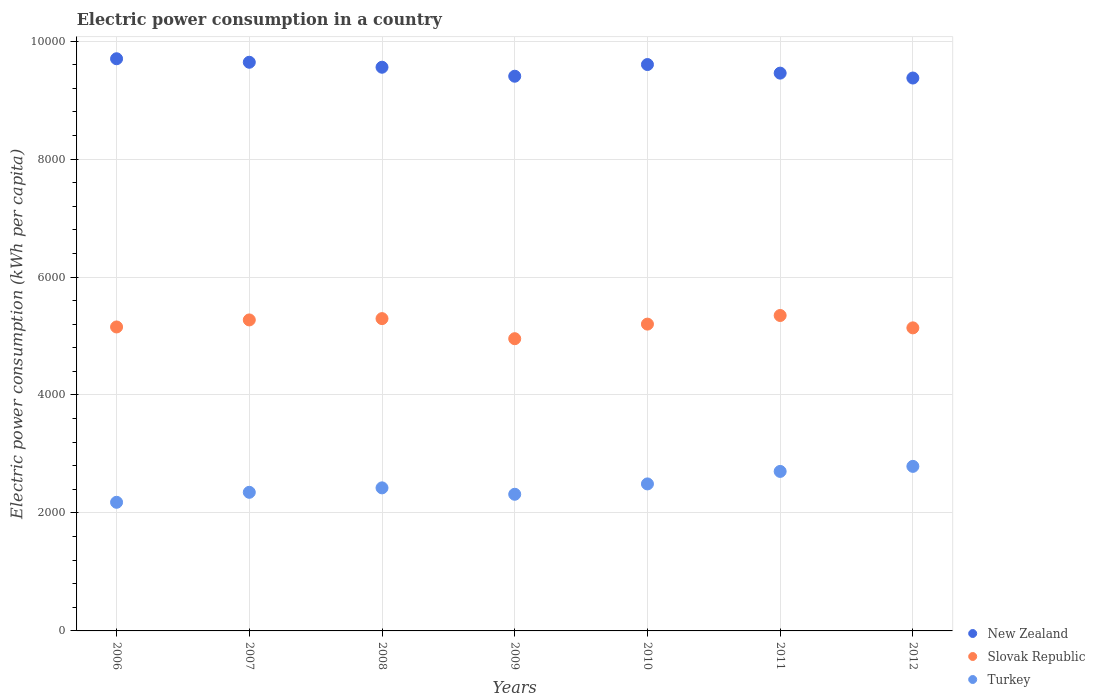How many different coloured dotlines are there?
Your answer should be compact. 3. What is the electric power consumption in in Slovak Republic in 2010?
Provide a succinct answer. 5201.4. Across all years, what is the maximum electric power consumption in in Slovak Republic?
Make the answer very short. 5347.53. Across all years, what is the minimum electric power consumption in in Slovak Republic?
Ensure brevity in your answer.  4954.14. What is the total electric power consumption in in Slovak Republic in the graph?
Your answer should be very brief. 3.64e+04. What is the difference between the electric power consumption in in Turkey in 2006 and that in 2011?
Provide a succinct answer. -523.33. What is the difference between the electric power consumption in in New Zealand in 2012 and the electric power consumption in in Slovak Republic in 2007?
Keep it short and to the point. 4101.06. What is the average electric power consumption in in Slovak Republic per year?
Your answer should be compact. 5194.4. In the year 2007, what is the difference between the electric power consumption in in Slovak Republic and electric power consumption in in Turkey?
Keep it short and to the point. 2922.49. What is the ratio of the electric power consumption in in Slovak Republic in 2008 to that in 2010?
Make the answer very short. 1.02. Is the electric power consumption in in Slovak Republic in 2006 less than that in 2011?
Your answer should be compact. Yes. Is the difference between the electric power consumption in in Slovak Republic in 2006 and 2012 greater than the difference between the electric power consumption in in Turkey in 2006 and 2012?
Your answer should be very brief. Yes. What is the difference between the highest and the second highest electric power consumption in in Turkey?
Give a very brief answer. 85.61. What is the difference between the highest and the lowest electric power consumption in in Slovak Republic?
Ensure brevity in your answer.  393.39. In how many years, is the electric power consumption in in Slovak Republic greater than the average electric power consumption in in Slovak Republic taken over all years?
Offer a terse response. 4. Does the electric power consumption in in Turkey monotonically increase over the years?
Provide a succinct answer. No. Is the electric power consumption in in Turkey strictly less than the electric power consumption in in Slovak Republic over the years?
Offer a terse response. Yes. How many years are there in the graph?
Make the answer very short. 7. Are the values on the major ticks of Y-axis written in scientific E-notation?
Your response must be concise. No. Where does the legend appear in the graph?
Ensure brevity in your answer.  Bottom right. How are the legend labels stacked?
Ensure brevity in your answer.  Vertical. What is the title of the graph?
Make the answer very short. Electric power consumption in a country. What is the label or title of the Y-axis?
Provide a short and direct response. Electric power consumption (kWh per capita). What is the Electric power consumption (kWh per capita) of New Zealand in 2006?
Give a very brief answer. 9700.09. What is the Electric power consumption (kWh per capita) of Slovak Republic in 2006?
Make the answer very short. 5153.12. What is the Electric power consumption (kWh per capita) in Turkey in 2006?
Make the answer very short. 2180.72. What is the Electric power consumption (kWh per capita) in New Zealand in 2007?
Offer a terse response. 9640.61. What is the Electric power consumption (kWh per capita) in Slovak Republic in 2007?
Offer a terse response. 5272.37. What is the Electric power consumption (kWh per capita) of Turkey in 2007?
Provide a short and direct response. 2349.88. What is the Electric power consumption (kWh per capita) in New Zealand in 2008?
Ensure brevity in your answer.  9556.32. What is the Electric power consumption (kWh per capita) in Slovak Republic in 2008?
Your response must be concise. 5294.44. What is the Electric power consumption (kWh per capita) of Turkey in 2008?
Provide a short and direct response. 2425.27. What is the Electric power consumption (kWh per capita) in New Zealand in 2009?
Make the answer very short. 9403.85. What is the Electric power consumption (kWh per capita) of Slovak Republic in 2009?
Provide a short and direct response. 4954.14. What is the Electric power consumption (kWh per capita) of Turkey in 2009?
Make the answer very short. 2316.64. What is the Electric power consumption (kWh per capita) in New Zealand in 2010?
Give a very brief answer. 9601.9. What is the Electric power consumption (kWh per capita) of Slovak Republic in 2010?
Make the answer very short. 5201.4. What is the Electric power consumption (kWh per capita) of Turkey in 2010?
Your answer should be compact. 2492.2. What is the Electric power consumption (kWh per capita) in New Zealand in 2011?
Offer a very short reply. 9456.2. What is the Electric power consumption (kWh per capita) in Slovak Republic in 2011?
Keep it short and to the point. 5347.53. What is the Electric power consumption (kWh per capita) in Turkey in 2011?
Provide a succinct answer. 2704.05. What is the Electric power consumption (kWh per capita) of New Zealand in 2012?
Keep it short and to the point. 9373.43. What is the Electric power consumption (kWh per capita) of Slovak Republic in 2012?
Provide a succinct answer. 5137.79. What is the Electric power consumption (kWh per capita) in Turkey in 2012?
Ensure brevity in your answer.  2789.66. Across all years, what is the maximum Electric power consumption (kWh per capita) in New Zealand?
Give a very brief answer. 9700.09. Across all years, what is the maximum Electric power consumption (kWh per capita) in Slovak Republic?
Give a very brief answer. 5347.53. Across all years, what is the maximum Electric power consumption (kWh per capita) of Turkey?
Provide a succinct answer. 2789.66. Across all years, what is the minimum Electric power consumption (kWh per capita) in New Zealand?
Offer a very short reply. 9373.43. Across all years, what is the minimum Electric power consumption (kWh per capita) of Slovak Republic?
Make the answer very short. 4954.14. Across all years, what is the minimum Electric power consumption (kWh per capita) in Turkey?
Your response must be concise. 2180.72. What is the total Electric power consumption (kWh per capita) of New Zealand in the graph?
Provide a succinct answer. 6.67e+04. What is the total Electric power consumption (kWh per capita) of Slovak Republic in the graph?
Offer a terse response. 3.64e+04. What is the total Electric power consumption (kWh per capita) in Turkey in the graph?
Provide a succinct answer. 1.73e+04. What is the difference between the Electric power consumption (kWh per capita) in New Zealand in 2006 and that in 2007?
Give a very brief answer. 59.48. What is the difference between the Electric power consumption (kWh per capita) of Slovak Republic in 2006 and that in 2007?
Make the answer very short. -119.25. What is the difference between the Electric power consumption (kWh per capita) in Turkey in 2006 and that in 2007?
Make the answer very short. -169.16. What is the difference between the Electric power consumption (kWh per capita) of New Zealand in 2006 and that in 2008?
Give a very brief answer. 143.77. What is the difference between the Electric power consumption (kWh per capita) of Slovak Republic in 2006 and that in 2008?
Provide a succinct answer. -141.31. What is the difference between the Electric power consumption (kWh per capita) in Turkey in 2006 and that in 2008?
Offer a terse response. -244.55. What is the difference between the Electric power consumption (kWh per capita) in New Zealand in 2006 and that in 2009?
Give a very brief answer. 296.24. What is the difference between the Electric power consumption (kWh per capita) in Slovak Republic in 2006 and that in 2009?
Make the answer very short. 198.98. What is the difference between the Electric power consumption (kWh per capita) of Turkey in 2006 and that in 2009?
Provide a succinct answer. -135.92. What is the difference between the Electric power consumption (kWh per capita) of New Zealand in 2006 and that in 2010?
Give a very brief answer. 98.19. What is the difference between the Electric power consumption (kWh per capita) in Slovak Republic in 2006 and that in 2010?
Offer a terse response. -48.28. What is the difference between the Electric power consumption (kWh per capita) of Turkey in 2006 and that in 2010?
Give a very brief answer. -311.48. What is the difference between the Electric power consumption (kWh per capita) in New Zealand in 2006 and that in 2011?
Offer a terse response. 243.89. What is the difference between the Electric power consumption (kWh per capita) in Slovak Republic in 2006 and that in 2011?
Give a very brief answer. -194.4. What is the difference between the Electric power consumption (kWh per capita) in Turkey in 2006 and that in 2011?
Give a very brief answer. -523.33. What is the difference between the Electric power consumption (kWh per capita) in New Zealand in 2006 and that in 2012?
Your response must be concise. 326.66. What is the difference between the Electric power consumption (kWh per capita) of Slovak Republic in 2006 and that in 2012?
Offer a terse response. 15.33. What is the difference between the Electric power consumption (kWh per capita) in Turkey in 2006 and that in 2012?
Give a very brief answer. -608.94. What is the difference between the Electric power consumption (kWh per capita) in New Zealand in 2007 and that in 2008?
Make the answer very short. 84.29. What is the difference between the Electric power consumption (kWh per capita) of Slovak Republic in 2007 and that in 2008?
Your answer should be compact. -22.06. What is the difference between the Electric power consumption (kWh per capita) in Turkey in 2007 and that in 2008?
Your response must be concise. -75.39. What is the difference between the Electric power consumption (kWh per capita) in New Zealand in 2007 and that in 2009?
Your answer should be very brief. 236.76. What is the difference between the Electric power consumption (kWh per capita) of Slovak Republic in 2007 and that in 2009?
Give a very brief answer. 318.23. What is the difference between the Electric power consumption (kWh per capita) of Turkey in 2007 and that in 2009?
Offer a terse response. 33.24. What is the difference between the Electric power consumption (kWh per capita) in New Zealand in 2007 and that in 2010?
Ensure brevity in your answer.  38.7. What is the difference between the Electric power consumption (kWh per capita) of Slovak Republic in 2007 and that in 2010?
Offer a very short reply. 70.97. What is the difference between the Electric power consumption (kWh per capita) of Turkey in 2007 and that in 2010?
Ensure brevity in your answer.  -142.32. What is the difference between the Electric power consumption (kWh per capita) in New Zealand in 2007 and that in 2011?
Ensure brevity in your answer.  184.4. What is the difference between the Electric power consumption (kWh per capita) in Slovak Republic in 2007 and that in 2011?
Offer a very short reply. -75.16. What is the difference between the Electric power consumption (kWh per capita) in Turkey in 2007 and that in 2011?
Provide a succinct answer. -354.17. What is the difference between the Electric power consumption (kWh per capita) in New Zealand in 2007 and that in 2012?
Your answer should be very brief. 267.18. What is the difference between the Electric power consumption (kWh per capita) of Slovak Republic in 2007 and that in 2012?
Offer a very short reply. 134.58. What is the difference between the Electric power consumption (kWh per capita) of Turkey in 2007 and that in 2012?
Give a very brief answer. -439.78. What is the difference between the Electric power consumption (kWh per capita) in New Zealand in 2008 and that in 2009?
Give a very brief answer. 152.47. What is the difference between the Electric power consumption (kWh per capita) in Slovak Republic in 2008 and that in 2009?
Keep it short and to the point. 340.3. What is the difference between the Electric power consumption (kWh per capita) in Turkey in 2008 and that in 2009?
Provide a succinct answer. 108.63. What is the difference between the Electric power consumption (kWh per capita) in New Zealand in 2008 and that in 2010?
Keep it short and to the point. -45.59. What is the difference between the Electric power consumption (kWh per capita) of Slovak Republic in 2008 and that in 2010?
Provide a short and direct response. 93.03. What is the difference between the Electric power consumption (kWh per capita) of Turkey in 2008 and that in 2010?
Your response must be concise. -66.93. What is the difference between the Electric power consumption (kWh per capita) in New Zealand in 2008 and that in 2011?
Make the answer very short. 100.11. What is the difference between the Electric power consumption (kWh per capita) in Slovak Republic in 2008 and that in 2011?
Give a very brief answer. -53.09. What is the difference between the Electric power consumption (kWh per capita) of Turkey in 2008 and that in 2011?
Give a very brief answer. -278.78. What is the difference between the Electric power consumption (kWh per capita) of New Zealand in 2008 and that in 2012?
Offer a very short reply. 182.89. What is the difference between the Electric power consumption (kWh per capita) in Slovak Republic in 2008 and that in 2012?
Your answer should be compact. 156.65. What is the difference between the Electric power consumption (kWh per capita) of Turkey in 2008 and that in 2012?
Offer a very short reply. -364.39. What is the difference between the Electric power consumption (kWh per capita) in New Zealand in 2009 and that in 2010?
Provide a succinct answer. -198.05. What is the difference between the Electric power consumption (kWh per capita) of Slovak Republic in 2009 and that in 2010?
Your answer should be compact. -247.27. What is the difference between the Electric power consumption (kWh per capita) of Turkey in 2009 and that in 2010?
Ensure brevity in your answer.  -175.56. What is the difference between the Electric power consumption (kWh per capita) of New Zealand in 2009 and that in 2011?
Offer a terse response. -52.36. What is the difference between the Electric power consumption (kWh per capita) of Slovak Republic in 2009 and that in 2011?
Your answer should be compact. -393.39. What is the difference between the Electric power consumption (kWh per capita) in Turkey in 2009 and that in 2011?
Provide a short and direct response. -387.41. What is the difference between the Electric power consumption (kWh per capita) of New Zealand in 2009 and that in 2012?
Provide a short and direct response. 30.42. What is the difference between the Electric power consumption (kWh per capita) of Slovak Republic in 2009 and that in 2012?
Offer a very short reply. -183.65. What is the difference between the Electric power consumption (kWh per capita) in Turkey in 2009 and that in 2012?
Ensure brevity in your answer.  -473.02. What is the difference between the Electric power consumption (kWh per capita) in New Zealand in 2010 and that in 2011?
Offer a terse response. 145.7. What is the difference between the Electric power consumption (kWh per capita) in Slovak Republic in 2010 and that in 2011?
Offer a terse response. -146.12. What is the difference between the Electric power consumption (kWh per capita) of Turkey in 2010 and that in 2011?
Your answer should be compact. -211.85. What is the difference between the Electric power consumption (kWh per capita) in New Zealand in 2010 and that in 2012?
Your answer should be very brief. 228.48. What is the difference between the Electric power consumption (kWh per capita) of Slovak Republic in 2010 and that in 2012?
Keep it short and to the point. 63.62. What is the difference between the Electric power consumption (kWh per capita) in Turkey in 2010 and that in 2012?
Ensure brevity in your answer.  -297.46. What is the difference between the Electric power consumption (kWh per capita) in New Zealand in 2011 and that in 2012?
Give a very brief answer. 82.78. What is the difference between the Electric power consumption (kWh per capita) in Slovak Republic in 2011 and that in 2012?
Give a very brief answer. 209.74. What is the difference between the Electric power consumption (kWh per capita) of Turkey in 2011 and that in 2012?
Provide a succinct answer. -85.61. What is the difference between the Electric power consumption (kWh per capita) in New Zealand in 2006 and the Electric power consumption (kWh per capita) in Slovak Republic in 2007?
Keep it short and to the point. 4427.72. What is the difference between the Electric power consumption (kWh per capita) in New Zealand in 2006 and the Electric power consumption (kWh per capita) in Turkey in 2007?
Keep it short and to the point. 7350.21. What is the difference between the Electric power consumption (kWh per capita) in Slovak Republic in 2006 and the Electric power consumption (kWh per capita) in Turkey in 2007?
Your answer should be compact. 2803.24. What is the difference between the Electric power consumption (kWh per capita) in New Zealand in 2006 and the Electric power consumption (kWh per capita) in Slovak Republic in 2008?
Offer a terse response. 4405.66. What is the difference between the Electric power consumption (kWh per capita) of New Zealand in 2006 and the Electric power consumption (kWh per capita) of Turkey in 2008?
Give a very brief answer. 7274.82. What is the difference between the Electric power consumption (kWh per capita) of Slovak Republic in 2006 and the Electric power consumption (kWh per capita) of Turkey in 2008?
Offer a terse response. 2727.85. What is the difference between the Electric power consumption (kWh per capita) of New Zealand in 2006 and the Electric power consumption (kWh per capita) of Slovak Republic in 2009?
Your response must be concise. 4745.95. What is the difference between the Electric power consumption (kWh per capita) in New Zealand in 2006 and the Electric power consumption (kWh per capita) in Turkey in 2009?
Give a very brief answer. 7383.45. What is the difference between the Electric power consumption (kWh per capita) of Slovak Republic in 2006 and the Electric power consumption (kWh per capita) of Turkey in 2009?
Give a very brief answer. 2836.48. What is the difference between the Electric power consumption (kWh per capita) in New Zealand in 2006 and the Electric power consumption (kWh per capita) in Slovak Republic in 2010?
Offer a very short reply. 4498.69. What is the difference between the Electric power consumption (kWh per capita) of New Zealand in 2006 and the Electric power consumption (kWh per capita) of Turkey in 2010?
Provide a succinct answer. 7207.89. What is the difference between the Electric power consumption (kWh per capita) of Slovak Republic in 2006 and the Electric power consumption (kWh per capita) of Turkey in 2010?
Ensure brevity in your answer.  2660.92. What is the difference between the Electric power consumption (kWh per capita) in New Zealand in 2006 and the Electric power consumption (kWh per capita) in Slovak Republic in 2011?
Offer a terse response. 4352.56. What is the difference between the Electric power consumption (kWh per capita) in New Zealand in 2006 and the Electric power consumption (kWh per capita) in Turkey in 2011?
Provide a short and direct response. 6996.04. What is the difference between the Electric power consumption (kWh per capita) of Slovak Republic in 2006 and the Electric power consumption (kWh per capita) of Turkey in 2011?
Make the answer very short. 2449.07. What is the difference between the Electric power consumption (kWh per capita) of New Zealand in 2006 and the Electric power consumption (kWh per capita) of Slovak Republic in 2012?
Your response must be concise. 4562.3. What is the difference between the Electric power consumption (kWh per capita) of New Zealand in 2006 and the Electric power consumption (kWh per capita) of Turkey in 2012?
Offer a very short reply. 6910.43. What is the difference between the Electric power consumption (kWh per capita) in Slovak Republic in 2006 and the Electric power consumption (kWh per capita) in Turkey in 2012?
Offer a terse response. 2363.46. What is the difference between the Electric power consumption (kWh per capita) of New Zealand in 2007 and the Electric power consumption (kWh per capita) of Slovak Republic in 2008?
Keep it short and to the point. 4346.17. What is the difference between the Electric power consumption (kWh per capita) in New Zealand in 2007 and the Electric power consumption (kWh per capita) in Turkey in 2008?
Your answer should be very brief. 7215.34. What is the difference between the Electric power consumption (kWh per capita) of Slovak Republic in 2007 and the Electric power consumption (kWh per capita) of Turkey in 2008?
Your answer should be very brief. 2847.1. What is the difference between the Electric power consumption (kWh per capita) of New Zealand in 2007 and the Electric power consumption (kWh per capita) of Slovak Republic in 2009?
Keep it short and to the point. 4686.47. What is the difference between the Electric power consumption (kWh per capita) of New Zealand in 2007 and the Electric power consumption (kWh per capita) of Turkey in 2009?
Make the answer very short. 7323.97. What is the difference between the Electric power consumption (kWh per capita) of Slovak Republic in 2007 and the Electric power consumption (kWh per capita) of Turkey in 2009?
Keep it short and to the point. 2955.73. What is the difference between the Electric power consumption (kWh per capita) of New Zealand in 2007 and the Electric power consumption (kWh per capita) of Slovak Republic in 2010?
Offer a terse response. 4439.2. What is the difference between the Electric power consumption (kWh per capita) of New Zealand in 2007 and the Electric power consumption (kWh per capita) of Turkey in 2010?
Ensure brevity in your answer.  7148.41. What is the difference between the Electric power consumption (kWh per capita) in Slovak Republic in 2007 and the Electric power consumption (kWh per capita) in Turkey in 2010?
Ensure brevity in your answer.  2780.17. What is the difference between the Electric power consumption (kWh per capita) of New Zealand in 2007 and the Electric power consumption (kWh per capita) of Slovak Republic in 2011?
Ensure brevity in your answer.  4293.08. What is the difference between the Electric power consumption (kWh per capita) in New Zealand in 2007 and the Electric power consumption (kWh per capita) in Turkey in 2011?
Provide a succinct answer. 6936.55. What is the difference between the Electric power consumption (kWh per capita) of Slovak Republic in 2007 and the Electric power consumption (kWh per capita) of Turkey in 2011?
Offer a very short reply. 2568.32. What is the difference between the Electric power consumption (kWh per capita) of New Zealand in 2007 and the Electric power consumption (kWh per capita) of Slovak Republic in 2012?
Keep it short and to the point. 4502.82. What is the difference between the Electric power consumption (kWh per capita) in New Zealand in 2007 and the Electric power consumption (kWh per capita) in Turkey in 2012?
Give a very brief answer. 6850.94. What is the difference between the Electric power consumption (kWh per capita) of Slovak Republic in 2007 and the Electric power consumption (kWh per capita) of Turkey in 2012?
Your answer should be compact. 2482.71. What is the difference between the Electric power consumption (kWh per capita) of New Zealand in 2008 and the Electric power consumption (kWh per capita) of Slovak Republic in 2009?
Your response must be concise. 4602.18. What is the difference between the Electric power consumption (kWh per capita) of New Zealand in 2008 and the Electric power consumption (kWh per capita) of Turkey in 2009?
Make the answer very short. 7239.67. What is the difference between the Electric power consumption (kWh per capita) of Slovak Republic in 2008 and the Electric power consumption (kWh per capita) of Turkey in 2009?
Provide a short and direct response. 2977.79. What is the difference between the Electric power consumption (kWh per capita) in New Zealand in 2008 and the Electric power consumption (kWh per capita) in Slovak Republic in 2010?
Offer a terse response. 4354.91. What is the difference between the Electric power consumption (kWh per capita) of New Zealand in 2008 and the Electric power consumption (kWh per capita) of Turkey in 2010?
Offer a very short reply. 7064.12. What is the difference between the Electric power consumption (kWh per capita) of Slovak Republic in 2008 and the Electric power consumption (kWh per capita) of Turkey in 2010?
Ensure brevity in your answer.  2802.24. What is the difference between the Electric power consumption (kWh per capita) in New Zealand in 2008 and the Electric power consumption (kWh per capita) in Slovak Republic in 2011?
Offer a terse response. 4208.79. What is the difference between the Electric power consumption (kWh per capita) in New Zealand in 2008 and the Electric power consumption (kWh per capita) in Turkey in 2011?
Provide a succinct answer. 6852.26. What is the difference between the Electric power consumption (kWh per capita) of Slovak Republic in 2008 and the Electric power consumption (kWh per capita) of Turkey in 2011?
Keep it short and to the point. 2590.38. What is the difference between the Electric power consumption (kWh per capita) in New Zealand in 2008 and the Electric power consumption (kWh per capita) in Slovak Republic in 2012?
Make the answer very short. 4418.53. What is the difference between the Electric power consumption (kWh per capita) of New Zealand in 2008 and the Electric power consumption (kWh per capita) of Turkey in 2012?
Offer a very short reply. 6766.65. What is the difference between the Electric power consumption (kWh per capita) of Slovak Republic in 2008 and the Electric power consumption (kWh per capita) of Turkey in 2012?
Ensure brevity in your answer.  2504.77. What is the difference between the Electric power consumption (kWh per capita) in New Zealand in 2009 and the Electric power consumption (kWh per capita) in Slovak Republic in 2010?
Keep it short and to the point. 4202.44. What is the difference between the Electric power consumption (kWh per capita) in New Zealand in 2009 and the Electric power consumption (kWh per capita) in Turkey in 2010?
Keep it short and to the point. 6911.65. What is the difference between the Electric power consumption (kWh per capita) in Slovak Republic in 2009 and the Electric power consumption (kWh per capita) in Turkey in 2010?
Your answer should be very brief. 2461.94. What is the difference between the Electric power consumption (kWh per capita) in New Zealand in 2009 and the Electric power consumption (kWh per capita) in Slovak Republic in 2011?
Make the answer very short. 4056.32. What is the difference between the Electric power consumption (kWh per capita) of New Zealand in 2009 and the Electric power consumption (kWh per capita) of Turkey in 2011?
Give a very brief answer. 6699.8. What is the difference between the Electric power consumption (kWh per capita) of Slovak Republic in 2009 and the Electric power consumption (kWh per capita) of Turkey in 2011?
Your answer should be compact. 2250.09. What is the difference between the Electric power consumption (kWh per capita) in New Zealand in 2009 and the Electric power consumption (kWh per capita) in Slovak Republic in 2012?
Ensure brevity in your answer.  4266.06. What is the difference between the Electric power consumption (kWh per capita) in New Zealand in 2009 and the Electric power consumption (kWh per capita) in Turkey in 2012?
Offer a terse response. 6614.19. What is the difference between the Electric power consumption (kWh per capita) of Slovak Republic in 2009 and the Electric power consumption (kWh per capita) of Turkey in 2012?
Provide a short and direct response. 2164.47. What is the difference between the Electric power consumption (kWh per capita) of New Zealand in 2010 and the Electric power consumption (kWh per capita) of Slovak Republic in 2011?
Keep it short and to the point. 4254.38. What is the difference between the Electric power consumption (kWh per capita) in New Zealand in 2010 and the Electric power consumption (kWh per capita) in Turkey in 2011?
Provide a succinct answer. 6897.85. What is the difference between the Electric power consumption (kWh per capita) in Slovak Republic in 2010 and the Electric power consumption (kWh per capita) in Turkey in 2011?
Provide a succinct answer. 2497.35. What is the difference between the Electric power consumption (kWh per capita) of New Zealand in 2010 and the Electric power consumption (kWh per capita) of Slovak Republic in 2012?
Provide a succinct answer. 4464.11. What is the difference between the Electric power consumption (kWh per capita) in New Zealand in 2010 and the Electric power consumption (kWh per capita) in Turkey in 2012?
Give a very brief answer. 6812.24. What is the difference between the Electric power consumption (kWh per capita) of Slovak Republic in 2010 and the Electric power consumption (kWh per capita) of Turkey in 2012?
Your answer should be very brief. 2411.74. What is the difference between the Electric power consumption (kWh per capita) of New Zealand in 2011 and the Electric power consumption (kWh per capita) of Slovak Republic in 2012?
Make the answer very short. 4318.42. What is the difference between the Electric power consumption (kWh per capita) of New Zealand in 2011 and the Electric power consumption (kWh per capita) of Turkey in 2012?
Provide a succinct answer. 6666.54. What is the difference between the Electric power consumption (kWh per capita) in Slovak Republic in 2011 and the Electric power consumption (kWh per capita) in Turkey in 2012?
Offer a terse response. 2557.86. What is the average Electric power consumption (kWh per capita) in New Zealand per year?
Keep it short and to the point. 9533.2. What is the average Electric power consumption (kWh per capita) in Slovak Republic per year?
Offer a terse response. 5194.4. What is the average Electric power consumption (kWh per capita) of Turkey per year?
Your response must be concise. 2465.49. In the year 2006, what is the difference between the Electric power consumption (kWh per capita) of New Zealand and Electric power consumption (kWh per capita) of Slovak Republic?
Make the answer very short. 4546.97. In the year 2006, what is the difference between the Electric power consumption (kWh per capita) of New Zealand and Electric power consumption (kWh per capita) of Turkey?
Offer a terse response. 7519.37. In the year 2006, what is the difference between the Electric power consumption (kWh per capita) in Slovak Republic and Electric power consumption (kWh per capita) in Turkey?
Provide a succinct answer. 2972.4. In the year 2007, what is the difference between the Electric power consumption (kWh per capita) of New Zealand and Electric power consumption (kWh per capita) of Slovak Republic?
Offer a terse response. 4368.24. In the year 2007, what is the difference between the Electric power consumption (kWh per capita) of New Zealand and Electric power consumption (kWh per capita) of Turkey?
Ensure brevity in your answer.  7290.73. In the year 2007, what is the difference between the Electric power consumption (kWh per capita) of Slovak Republic and Electric power consumption (kWh per capita) of Turkey?
Offer a terse response. 2922.49. In the year 2008, what is the difference between the Electric power consumption (kWh per capita) of New Zealand and Electric power consumption (kWh per capita) of Slovak Republic?
Keep it short and to the point. 4261.88. In the year 2008, what is the difference between the Electric power consumption (kWh per capita) in New Zealand and Electric power consumption (kWh per capita) in Turkey?
Provide a short and direct response. 7131.05. In the year 2008, what is the difference between the Electric power consumption (kWh per capita) in Slovak Republic and Electric power consumption (kWh per capita) in Turkey?
Offer a very short reply. 2869.17. In the year 2009, what is the difference between the Electric power consumption (kWh per capita) in New Zealand and Electric power consumption (kWh per capita) in Slovak Republic?
Offer a very short reply. 4449.71. In the year 2009, what is the difference between the Electric power consumption (kWh per capita) of New Zealand and Electric power consumption (kWh per capita) of Turkey?
Ensure brevity in your answer.  7087.21. In the year 2009, what is the difference between the Electric power consumption (kWh per capita) in Slovak Republic and Electric power consumption (kWh per capita) in Turkey?
Offer a very short reply. 2637.5. In the year 2010, what is the difference between the Electric power consumption (kWh per capita) of New Zealand and Electric power consumption (kWh per capita) of Slovak Republic?
Provide a succinct answer. 4400.5. In the year 2010, what is the difference between the Electric power consumption (kWh per capita) in New Zealand and Electric power consumption (kWh per capita) in Turkey?
Provide a succinct answer. 7109.7. In the year 2010, what is the difference between the Electric power consumption (kWh per capita) in Slovak Republic and Electric power consumption (kWh per capita) in Turkey?
Your answer should be very brief. 2709.21. In the year 2011, what is the difference between the Electric power consumption (kWh per capita) of New Zealand and Electric power consumption (kWh per capita) of Slovak Republic?
Offer a very short reply. 4108.68. In the year 2011, what is the difference between the Electric power consumption (kWh per capita) in New Zealand and Electric power consumption (kWh per capita) in Turkey?
Make the answer very short. 6752.15. In the year 2011, what is the difference between the Electric power consumption (kWh per capita) of Slovak Republic and Electric power consumption (kWh per capita) of Turkey?
Give a very brief answer. 2643.47. In the year 2012, what is the difference between the Electric power consumption (kWh per capita) in New Zealand and Electric power consumption (kWh per capita) in Slovak Republic?
Ensure brevity in your answer.  4235.64. In the year 2012, what is the difference between the Electric power consumption (kWh per capita) in New Zealand and Electric power consumption (kWh per capita) in Turkey?
Offer a terse response. 6583.76. In the year 2012, what is the difference between the Electric power consumption (kWh per capita) of Slovak Republic and Electric power consumption (kWh per capita) of Turkey?
Your response must be concise. 2348.13. What is the ratio of the Electric power consumption (kWh per capita) in New Zealand in 2006 to that in 2007?
Give a very brief answer. 1.01. What is the ratio of the Electric power consumption (kWh per capita) of Slovak Republic in 2006 to that in 2007?
Provide a succinct answer. 0.98. What is the ratio of the Electric power consumption (kWh per capita) of Turkey in 2006 to that in 2007?
Offer a terse response. 0.93. What is the ratio of the Electric power consumption (kWh per capita) of Slovak Republic in 2006 to that in 2008?
Provide a short and direct response. 0.97. What is the ratio of the Electric power consumption (kWh per capita) in Turkey in 2006 to that in 2008?
Your response must be concise. 0.9. What is the ratio of the Electric power consumption (kWh per capita) of New Zealand in 2006 to that in 2009?
Make the answer very short. 1.03. What is the ratio of the Electric power consumption (kWh per capita) in Slovak Republic in 2006 to that in 2009?
Your response must be concise. 1.04. What is the ratio of the Electric power consumption (kWh per capita) of Turkey in 2006 to that in 2009?
Provide a succinct answer. 0.94. What is the ratio of the Electric power consumption (kWh per capita) of New Zealand in 2006 to that in 2010?
Ensure brevity in your answer.  1.01. What is the ratio of the Electric power consumption (kWh per capita) in Turkey in 2006 to that in 2010?
Ensure brevity in your answer.  0.88. What is the ratio of the Electric power consumption (kWh per capita) of New Zealand in 2006 to that in 2011?
Your answer should be compact. 1.03. What is the ratio of the Electric power consumption (kWh per capita) of Slovak Republic in 2006 to that in 2011?
Make the answer very short. 0.96. What is the ratio of the Electric power consumption (kWh per capita) in Turkey in 2006 to that in 2011?
Offer a very short reply. 0.81. What is the ratio of the Electric power consumption (kWh per capita) in New Zealand in 2006 to that in 2012?
Keep it short and to the point. 1.03. What is the ratio of the Electric power consumption (kWh per capita) of Turkey in 2006 to that in 2012?
Offer a very short reply. 0.78. What is the ratio of the Electric power consumption (kWh per capita) of New Zealand in 2007 to that in 2008?
Your response must be concise. 1.01. What is the ratio of the Electric power consumption (kWh per capita) of Slovak Republic in 2007 to that in 2008?
Make the answer very short. 1. What is the ratio of the Electric power consumption (kWh per capita) of Turkey in 2007 to that in 2008?
Offer a very short reply. 0.97. What is the ratio of the Electric power consumption (kWh per capita) of New Zealand in 2007 to that in 2009?
Offer a terse response. 1.03. What is the ratio of the Electric power consumption (kWh per capita) of Slovak Republic in 2007 to that in 2009?
Your response must be concise. 1.06. What is the ratio of the Electric power consumption (kWh per capita) of Turkey in 2007 to that in 2009?
Keep it short and to the point. 1.01. What is the ratio of the Electric power consumption (kWh per capita) of Slovak Republic in 2007 to that in 2010?
Offer a terse response. 1.01. What is the ratio of the Electric power consumption (kWh per capita) in Turkey in 2007 to that in 2010?
Keep it short and to the point. 0.94. What is the ratio of the Electric power consumption (kWh per capita) in New Zealand in 2007 to that in 2011?
Keep it short and to the point. 1.02. What is the ratio of the Electric power consumption (kWh per capita) of Slovak Republic in 2007 to that in 2011?
Your answer should be compact. 0.99. What is the ratio of the Electric power consumption (kWh per capita) in Turkey in 2007 to that in 2011?
Provide a short and direct response. 0.87. What is the ratio of the Electric power consumption (kWh per capita) in New Zealand in 2007 to that in 2012?
Your answer should be compact. 1.03. What is the ratio of the Electric power consumption (kWh per capita) in Slovak Republic in 2007 to that in 2012?
Make the answer very short. 1.03. What is the ratio of the Electric power consumption (kWh per capita) in Turkey in 2007 to that in 2012?
Give a very brief answer. 0.84. What is the ratio of the Electric power consumption (kWh per capita) in New Zealand in 2008 to that in 2009?
Offer a terse response. 1.02. What is the ratio of the Electric power consumption (kWh per capita) of Slovak Republic in 2008 to that in 2009?
Make the answer very short. 1.07. What is the ratio of the Electric power consumption (kWh per capita) in Turkey in 2008 to that in 2009?
Your answer should be very brief. 1.05. What is the ratio of the Electric power consumption (kWh per capita) in Slovak Republic in 2008 to that in 2010?
Provide a succinct answer. 1.02. What is the ratio of the Electric power consumption (kWh per capita) in Turkey in 2008 to that in 2010?
Offer a very short reply. 0.97. What is the ratio of the Electric power consumption (kWh per capita) of New Zealand in 2008 to that in 2011?
Offer a very short reply. 1.01. What is the ratio of the Electric power consumption (kWh per capita) of Slovak Republic in 2008 to that in 2011?
Your response must be concise. 0.99. What is the ratio of the Electric power consumption (kWh per capita) of Turkey in 2008 to that in 2011?
Offer a very short reply. 0.9. What is the ratio of the Electric power consumption (kWh per capita) in New Zealand in 2008 to that in 2012?
Provide a short and direct response. 1.02. What is the ratio of the Electric power consumption (kWh per capita) of Slovak Republic in 2008 to that in 2012?
Provide a short and direct response. 1.03. What is the ratio of the Electric power consumption (kWh per capita) in Turkey in 2008 to that in 2012?
Offer a terse response. 0.87. What is the ratio of the Electric power consumption (kWh per capita) in New Zealand in 2009 to that in 2010?
Provide a succinct answer. 0.98. What is the ratio of the Electric power consumption (kWh per capita) in Slovak Republic in 2009 to that in 2010?
Ensure brevity in your answer.  0.95. What is the ratio of the Electric power consumption (kWh per capita) in Turkey in 2009 to that in 2010?
Give a very brief answer. 0.93. What is the ratio of the Electric power consumption (kWh per capita) of Slovak Republic in 2009 to that in 2011?
Your answer should be very brief. 0.93. What is the ratio of the Electric power consumption (kWh per capita) of Turkey in 2009 to that in 2011?
Your answer should be very brief. 0.86. What is the ratio of the Electric power consumption (kWh per capita) in New Zealand in 2009 to that in 2012?
Give a very brief answer. 1. What is the ratio of the Electric power consumption (kWh per capita) of Turkey in 2009 to that in 2012?
Provide a succinct answer. 0.83. What is the ratio of the Electric power consumption (kWh per capita) in New Zealand in 2010 to that in 2011?
Your answer should be very brief. 1.02. What is the ratio of the Electric power consumption (kWh per capita) in Slovak Republic in 2010 to that in 2011?
Your answer should be very brief. 0.97. What is the ratio of the Electric power consumption (kWh per capita) in Turkey in 2010 to that in 2011?
Keep it short and to the point. 0.92. What is the ratio of the Electric power consumption (kWh per capita) of New Zealand in 2010 to that in 2012?
Your answer should be very brief. 1.02. What is the ratio of the Electric power consumption (kWh per capita) of Slovak Republic in 2010 to that in 2012?
Provide a succinct answer. 1.01. What is the ratio of the Electric power consumption (kWh per capita) in Turkey in 2010 to that in 2012?
Provide a short and direct response. 0.89. What is the ratio of the Electric power consumption (kWh per capita) of New Zealand in 2011 to that in 2012?
Your answer should be compact. 1.01. What is the ratio of the Electric power consumption (kWh per capita) of Slovak Republic in 2011 to that in 2012?
Your answer should be very brief. 1.04. What is the ratio of the Electric power consumption (kWh per capita) of Turkey in 2011 to that in 2012?
Your answer should be very brief. 0.97. What is the difference between the highest and the second highest Electric power consumption (kWh per capita) in New Zealand?
Give a very brief answer. 59.48. What is the difference between the highest and the second highest Electric power consumption (kWh per capita) of Slovak Republic?
Give a very brief answer. 53.09. What is the difference between the highest and the second highest Electric power consumption (kWh per capita) of Turkey?
Ensure brevity in your answer.  85.61. What is the difference between the highest and the lowest Electric power consumption (kWh per capita) in New Zealand?
Provide a succinct answer. 326.66. What is the difference between the highest and the lowest Electric power consumption (kWh per capita) in Slovak Republic?
Make the answer very short. 393.39. What is the difference between the highest and the lowest Electric power consumption (kWh per capita) of Turkey?
Give a very brief answer. 608.94. 